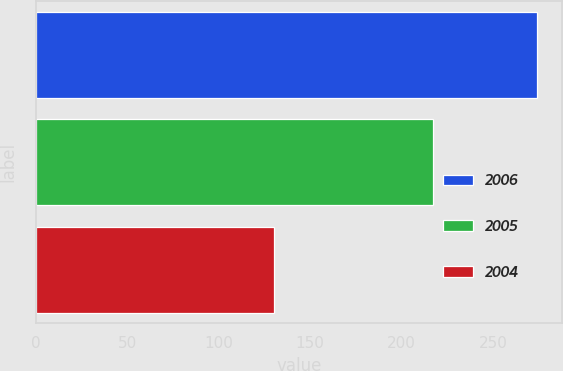Convert chart. <chart><loc_0><loc_0><loc_500><loc_500><bar_chart><fcel>2006<fcel>2005<fcel>2004<nl><fcel>274<fcel>217<fcel>130<nl></chart> 